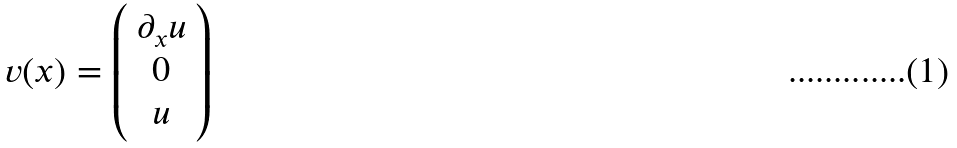Convert formula to latex. <formula><loc_0><loc_0><loc_500><loc_500>v ( x ) = \left ( \begin{array} { c } { { \partial _ { x } u } } \\ { 0 } \\ { u } \end{array} \right )</formula> 